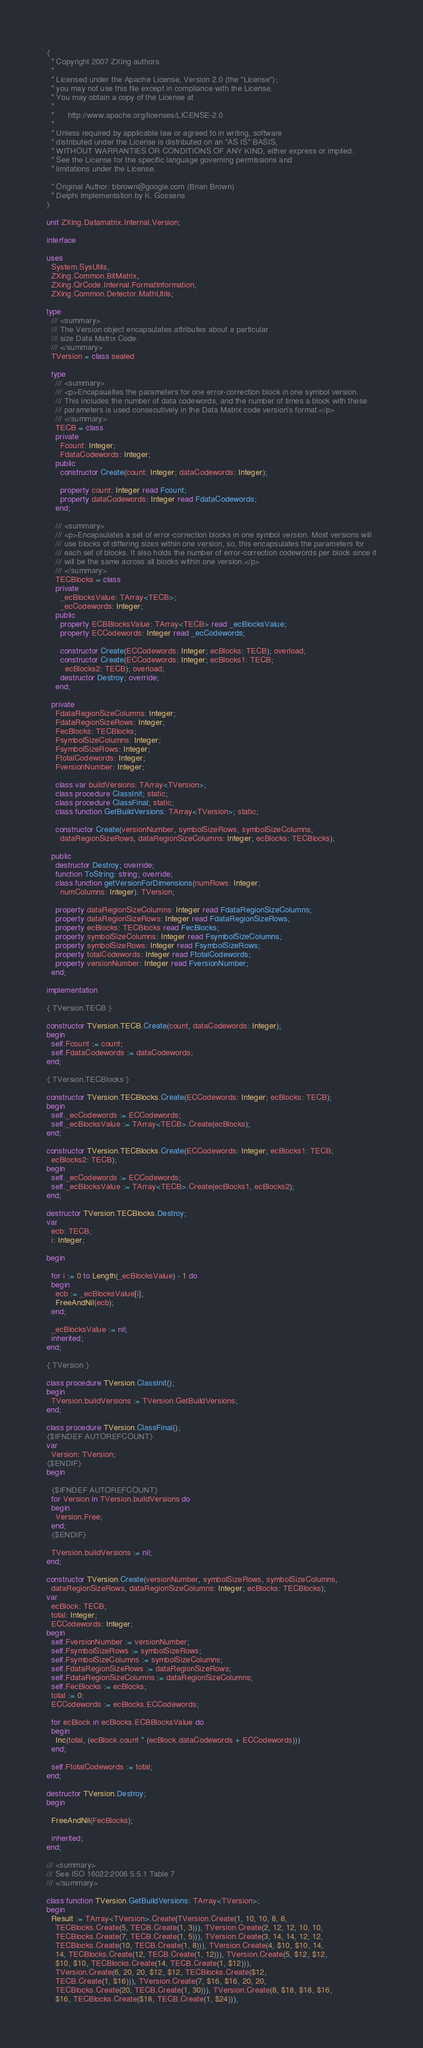Convert code to text. <code><loc_0><loc_0><loc_500><loc_500><_Pascal_>{
  * Copyright 2007 ZXing authors
  *
  * Licensed under the Apache License, Version 2.0 (the "License");
  * you may not use this file except in compliance with the License.
  * You may obtain a copy of the License at
  *
  *      http://www.apache.org/licenses/LICENSE-2.0
  *
  * Unless required by applicable law or agreed to in writing, software
  * distributed under the License is distributed on an "AS IS" BASIS,
  * WITHOUT WARRANTIES OR CONDITIONS OF ANY KIND, either express or implied.
  * See the License for the specific language governing permissions and
  * limitations under the License.

  * Original Author: bbrown@google.com (Brian Brown)
  * Delphi Implementation by K. Gossens
}

unit ZXing.Datamatrix.Internal.Version;

interface

uses
  System.SysUtils,
  ZXing.Common.BitMatrix,
  ZXing.QrCode.Internal.FormatInformation,
  ZXing.Common.Detector.MathUtils;

type
  /// <summary>
  /// The Version object encapsulates attributes about a particular
  /// size Data Matrix Code.
  /// </summary>
  TVersion = class sealed

  type
    /// <summary>
    /// <p>Encapsualtes the parameters for one error-correction block in one symbol version.
    /// This includes the number of data codewords, and the number of times a block with these
    /// parameters is used consecutively in the Data Matrix code version's format.</p>
    /// </summary>
    TECB = class
    private
      Fcount: Integer;
      FdataCodewords: Integer;
    public
      constructor Create(count: Integer; dataCodewords: Integer);

      property count: Integer read Fcount;
      property dataCodewords: Integer read FdataCodewords;
    end;

    /// <summary>
    /// <p>Encapsulates a set of error-correction blocks in one symbol version. Most versions will
    /// use blocks of differing sizes within one version, so, this encapsulates the parameters for
    /// each set of blocks. It also holds the number of error-correction codewords per block since it
    /// will be the same across all blocks within one version.</p>
    /// </summary>
    TECBlocks = class
    private
      _ecBlocksValue: TArray<TECB>;
      _ecCodewords: Integer;
    public
      property ECBBlocksValue: TArray<TECB> read _ecBlocksValue;
      property ECCodewords: Integer read _ecCodewords;

      constructor Create(ECCodewords: Integer; ecBlocks: TECB); overload;
      constructor Create(ECCodewords: Integer; ecBlocks1: TECB;
        ecBlocks2: TECB); overload;
      destructor Destroy; override;
    end;

  private
    FdataRegionSizeColumns: Integer;
    FdataRegionSizeRows: Integer;
    FecBlocks: TECBlocks;
    FsymbolSizeColumns: Integer;
    FsymbolSizeRows: Integer;
    FtotalCodewords: Integer;
    FversionNumber: Integer;

    class var buildVersions: TArray<TVersion>;
    class procedure ClassInit; static;
    class procedure ClassFinal; static;
    class function GetBuildVersions: TArray<TVersion>; static;

    constructor Create(versionNumber, symbolSizeRows, symbolSizeColumns,
      dataRegionSizeRows, dataRegionSizeColumns: Integer; ecBlocks: TECBlocks);

  public
    destructor Destroy; override;
    function ToString: string; override;
    class function getVersionForDimensions(numRows: Integer;
      numColumns: Integer): TVersion;

    property dataRegionSizeColumns: Integer read FdataRegionSizeColumns;
    property dataRegionSizeRows: Integer read FdataRegionSizeRows;
    property ecBlocks: TECBlocks read FecBlocks;
    property symbolSizeColumns: Integer read FsymbolSizeColumns;
    property symbolSizeRows: Integer read FsymbolSizeRows;
    property totalCodewords: Integer read FtotalCodewords;
    property versionNumber: Integer read FversionNumber;
  end;

implementation

{ TVersion.TECB }

constructor TVersion.TECB.Create(count, dataCodewords: Integer);
begin
  self.Fcount := count;
  self.FdataCodewords := dataCodewords;
end;

{ TVersion.TECBlocks }

constructor TVersion.TECBlocks.Create(ECCodewords: Integer; ecBlocks: TECB);
begin
  self._ecCodewords := ECCodewords;
  self._ecBlocksValue := TArray<TECB>.Create(ecBlocks);
end;

constructor TVersion.TECBlocks.Create(ECCodewords: Integer; ecBlocks1: TECB;
  ecBlocks2: TECB);
begin
  self._ecCodewords := ECCodewords;
  self._ecBlocksValue := TArray<TECB>.Create(ecBlocks1, ecBlocks2);
end;

destructor TVersion.TECBlocks.Destroy;
var
  ecb: TECB;
  i: Integer;

begin

  for i := 0 to Length(_ecBlocksValue) - 1 do
  begin
    ecb := _ecBlocksValue[i];
    FreeAndNil(ecb);
  end;

  _ecBlocksValue := nil;
  inherited;
end;

{ TVersion }

class procedure TVersion.ClassInit();
begin
  TVersion.buildVersions := TVersion.GetBuildVersions;
end;

class procedure TVersion.ClassFinal();
{$IFNDEF AUTOREFCOUNT}
var
  Version: TVersion;
{$ENDIF}
begin

  {$IFNDEF AUTOREFCOUNT}
  for Version in TVersion.buildVersions do
  begin
    Version.Free;
  end;
  {$ENDIF}

  TVersion.buildVersions := nil;
end;

constructor TVersion.Create(versionNumber, symbolSizeRows, symbolSizeColumns,
  dataRegionSizeRows, dataRegionSizeColumns: Integer; ecBlocks: TECBlocks);
var
  ecBlock: TECB;
  total: Integer;
  ECCodewords: Integer;
begin
  self.FversionNumber := versionNumber;
  self.FsymbolSizeRows := symbolSizeRows;
  self.FsymbolSizeColumns := symbolSizeColumns;
  self.FdataRegionSizeRows := dataRegionSizeRows;
  self.FdataRegionSizeColumns := dataRegionSizeColumns;
  self.FecBlocks := ecBlocks;
  total := 0;
  ECCodewords := ecBlocks.ECCodewords;

  for ecBlock in ecBlocks.ECBBlocksValue do
  begin
    Inc(total, (ecBlock.count * (ecBlock.dataCodewords + ECCodewords)))
  end;

  self.FtotalCodewords := total;
end;

destructor TVersion.Destroy;
begin

  FreeAndNil(FecBlocks);

  inherited;
end;

/// <summary>
/// See ISO 16022:2006 5.5.1 Table 7
/// </summary>

class function TVersion.GetBuildVersions: TArray<TVersion>;
begin
  Result := TArray<TVersion>.Create(TVersion.Create(1, 10, 10, 8, 8,
    TECBlocks.Create(5, TECB.Create(1, 3))), TVersion.Create(2, 12, 12, 10, 10,
    TECBlocks.Create(7, TECB.Create(1, 5))), TVersion.Create(3, 14, 14, 12, 12,
    TECBlocks.Create(10, TECB.Create(1, 8))), TVersion.Create(4, $10, $10, 14,
    14, TECBlocks.Create(12, TECB.Create(1, 12))), TVersion.Create(5, $12, $12,
    $10, $10, TECBlocks.Create(14, TECB.Create(1, $12))),
    TVersion.Create(6, 20, 20, $12, $12, TECBlocks.Create($12,
    TECB.Create(1, $16))), TVersion.Create(7, $16, $16, 20, 20,
    TECBlocks.Create(20, TECB.Create(1, 30))), TVersion.Create(8, $18, $18, $16,
    $16, TECBlocks.Create($18, TECB.Create(1, $24))),</code> 